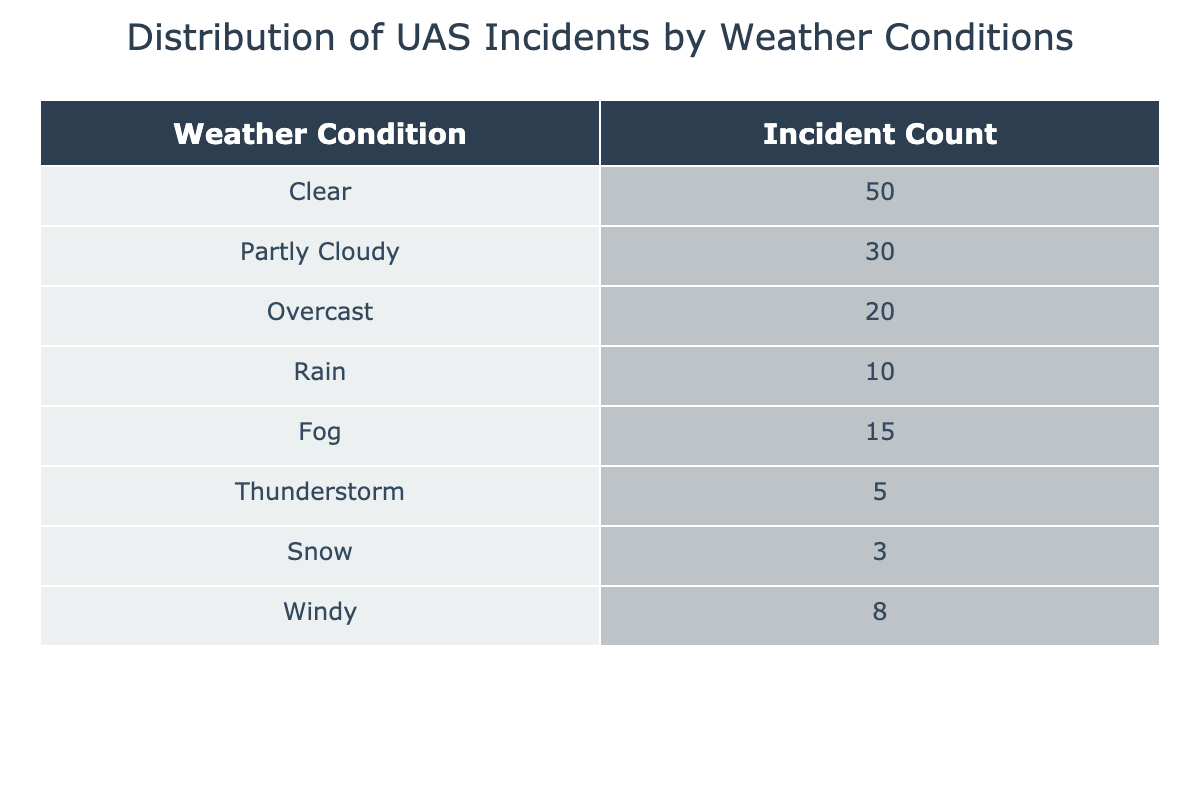What is the total number of incidents reported in clear weather? There is a specific row in the table where the weather condition is "Clear." The incident count corresponding to this condition is 50.
Answer: 50 What is the weather condition with the least number of incidents? The table lists incidents for various weather conditions. The one with the least incident count is "Snow," which has 3 incidents.
Answer: Snow How many incidents occurred in overcast weather? In the table, the row labeled "Overcast" shows a count of incidents, which is 20.
Answer: 20 What is the total number of incidents across all weather conditions? To find the total, we sum all the incident counts: 50 + 30 + 20 + 10 + 15 + 5 + 3 + 8 = 141. Thus, the total incidents are 141.
Answer: 141 Is there a higher number of incidents in rainy conditions compared to snowy conditions? The incident count for "Rain" is 10, while for "Snow" it is 3. Since 10 is greater than 3, the statement is true.
Answer: Yes What is the average number of incidents across all weather conditions? The total incidents are 141 (calculated before) and there are 8 different weather conditions. To find the average, we divide total incidents by the number of conditions: 141 / 8 = 17.625. Therefore, the average rounded to two decimal places is 17.63.
Answer: 17.63 How many more incidents were recorded in Fog compared to Thunderstorm? The incident count for "Fog" is 15 and for "Thunderstorm" it is 5. To find the difference, we subtract: 15 - 5 = 10. Therefore, there were 10 more incidents in Fog.
Answer: 10 Are there any incidents recorded during Windy weather that exceed those during thunderstorm conditions? The count for "Windy" is 8 incidents while "Thunderstorm" has 5. Since 8 is greater than 5, the statement is true.
Answer: Yes 